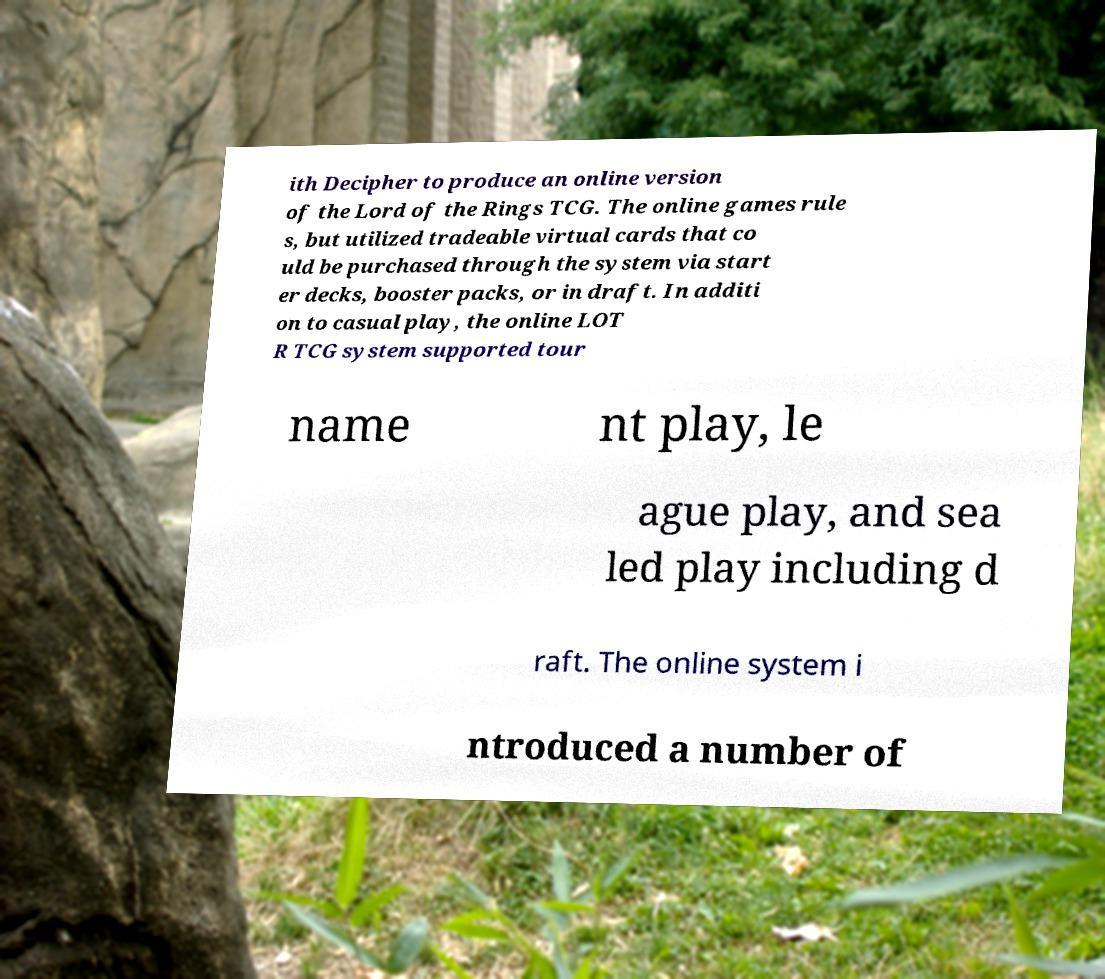Please read and relay the text visible in this image. What does it say? ith Decipher to produce an online version of the Lord of the Rings TCG. The online games rule s, but utilized tradeable virtual cards that co uld be purchased through the system via start er decks, booster packs, or in draft. In additi on to casual play, the online LOT R TCG system supported tour name nt play, le ague play, and sea led play including d raft. The online system i ntroduced a number of 